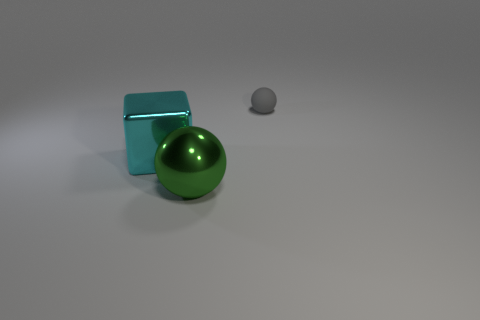What number of cyan objects are either small matte cylinders or large blocks?
Provide a short and direct response. 1. There is a metallic sphere; are there any large green balls behind it?
Ensure brevity in your answer.  No. There is a big metallic object that is right of the metal cube; is it the same shape as the large metallic object that is behind the metallic ball?
Give a very brief answer. No. There is a green object that is the same shape as the small gray thing; what is its material?
Ensure brevity in your answer.  Metal. What number of cubes are either green objects or red objects?
Your answer should be very brief. 0. What number of big green things are made of the same material as the cyan block?
Your response must be concise. 1. Is the material of the thing that is left of the green shiny object the same as the ball behind the large green metal ball?
Provide a succinct answer. No. What number of small balls are on the left side of the sphere in front of the ball that is right of the green metallic thing?
Your response must be concise. 0. There is a big thing that is to the right of the large cyan shiny object; is it the same color as the metal thing on the left side of the shiny ball?
Give a very brief answer. No. Is there anything else that has the same color as the big metal sphere?
Offer a terse response. No. 